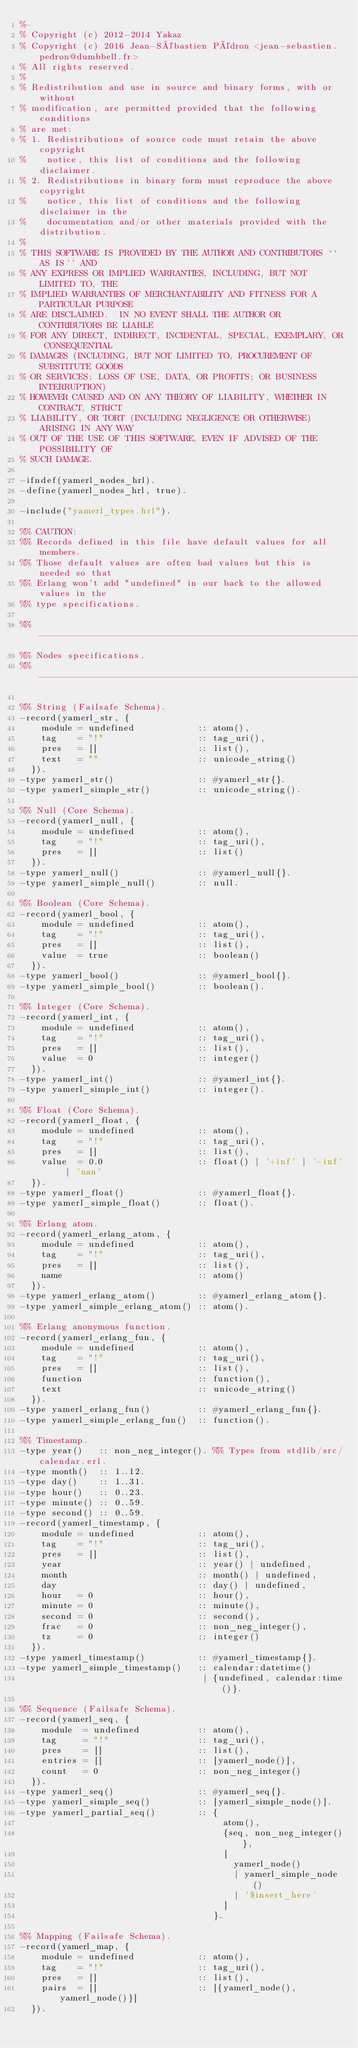<code> <loc_0><loc_0><loc_500><loc_500><_Erlang_>%-
% Copyright (c) 2012-2014 Yakaz
% Copyright (c) 2016 Jean-Sébastien Pédron <jean-sebastien.pedron@dumbbell.fr>
% All rights reserved.
%
% Redistribution and use in source and binary forms, with or without
% modification, are permitted provided that the following conditions
% are met:
% 1. Redistributions of source code must retain the above copyright
%    notice, this list of conditions and the following disclaimer.
% 2. Redistributions in binary form must reproduce the above copyright
%    notice, this list of conditions and the following disclaimer in the
%    documentation and/or other materials provided with the distribution.
%
% THIS SOFTWARE IS PROVIDED BY THE AUTHOR AND CONTRIBUTORS ``AS IS'' AND
% ANY EXPRESS OR IMPLIED WARRANTIES, INCLUDING, BUT NOT LIMITED TO, THE
% IMPLIED WARRANTIES OF MERCHANTABILITY AND FITNESS FOR A PARTICULAR PURPOSE
% ARE DISCLAIMED.  IN NO EVENT SHALL THE AUTHOR OR CONTRIBUTORS BE LIABLE
% FOR ANY DIRECT, INDIRECT, INCIDENTAL, SPECIAL, EXEMPLARY, OR CONSEQUENTIAL
% DAMAGES (INCLUDING, BUT NOT LIMITED TO, PROCUREMENT OF SUBSTITUTE GOODS
% OR SERVICES; LOSS OF USE, DATA, OR PROFITS; OR BUSINESS INTERRUPTION)
% HOWEVER CAUSED AND ON ANY THEORY OF LIABILITY, WHETHER IN CONTRACT, STRICT
% LIABILITY, OR TORT (INCLUDING NEGLIGENCE OR OTHERWISE) ARISING IN ANY WAY
% OUT OF THE USE OF THIS SOFTWARE, EVEN IF ADVISED OF THE POSSIBILITY OF
% SUCH DAMAGE.

-ifndef(yamerl_nodes_hrl).
-define(yamerl_nodes_hrl, true).

-include("yamerl_types.hrl").

%% CAUTION:
%% Records defined in this file have default values for all members.
%% Those default values are often bad values but this is needed so that
%% Erlang won't add "undefined" in our back to the allowed values in the
%% type specifications.

%% -------------------------------------------------------------------
%% Nodes specifications.
%% -------------------------------------------------------------------

%% String (Failsafe Schema).
-record(yamerl_str, {
    module = undefined            :: atom(),
    tag    = "!"                  :: tag_uri(),
    pres   = []                   :: list(),
    text   = ""                   :: unicode_string()
  }).
-type yamerl_str()                :: #yamerl_str{}.
-type yamerl_simple_str()         :: unicode_string().

%% Null (Core Schema).
-record(yamerl_null, {
    module = undefined            :: atom(),
    tag    = "!"                  :: tag_uri(),
    pres   = []                   :: list()
  }).
-type yamerl_null()               :: #yamerl_null{}.
-type yamerl_simple_null()        :: null.

%% Boolean (Core Schema).
-record(yamerl_bool, {
    module = undefined            :: atom(),
    tag    = "!"                  :: tag_uri(),
    pres   = []                   :: list(),
    value  = true                 :: boolean()
  }).
-type yamerl_bool()               :: #yamerl_bool{}.
-type yamerl_simple_bool()        :: boolean().

%% Integer (Core Schema).
-record(yamerl_int, {
    module = undefined            :: atom(),
    tag    = "!"                  :: tag_uri(),
    pres   = []                   :: list(),
    value  = 0                    :: integer()
  }).
-type yamerl_int()                :: #yamerl_int{}.
-type yamerl_simple_int()         :: integer().

%% Float (Core Schema).
-record(yamerl_float, {
    module = undefined            :: atom(),
    tag    = "!"                  :: tag_uri(),
    pres   = []                   :: list(),
    value  = 0.0                  :: float() | '+inf' | '-inf' | 'nan'
  }).
-type yamerl_float()              :: #yamerl_float{}.
-type yamerl_simple_float()       :: float().

%% Erlang atom.
-record(yamerl_erlang_atom, {
    module = undefined            :: atom(),
    tag    = "!"                  :: tag_uri(),
    pres   = []                   :: list(),
    name                          :: atom()
  }).
-type yamerl_erlang_atom()        :: #yamerl_erlang_atom{}.
-type yamerl_simple_erlang_atom() :: atom().

%% Erlang anonymous function.
-record(yamerl_erlang_fun, {
    module = undefined            :: atom(),
    tag    = "!"                  :: tag_uri(),
    pres   = []                   :: list(),
    function                      :: function(),
    text                          :: unicode_string()
  }).
-type yamerl_erlang_fun()         :: #yamerl_erlang_fun{}.
-type yamerl_simple_erlang_fun()  :: function().

%% Timestamp.
-type year()   :: non_neg_integer(). %% Types from stdlib/src/calendar.erl.
-type month()  :: 1..12.
-type day()    :: 1..31.
-type hour()   :: 0..23.
-type minute() :: 0..59.
-type second() :: 0..59.
-record(yamerl_timestamp, {
    module = undefined            :: atom(),
    tag    = "!"                  :: tag_uri(),
    pres   = []                   :: list(),
    year                          :: year() | undefined,
    month                         :: month() | undefined,
    day                           :: day() | undefined,
    hour   = 0                    :: hour(),
    minute = 0                    :: minute(),
    second = 0                    :: second(),
    frac   = 0                    :: non_neg_integer(),
    tz     = 0                    :: integer()
  }).
-type yamerl_timestamp()          :: #yamerl_timestamp{}.
-type yamerl_simple_timestamp()   :: calendar:datetime()
                                   | {undefined, calendar:time()}.

%% Sequence (Failsafe Schema).
-record(yamerl_seq, {
    module  = undefined           :: atom(),
    tag     = "!"                 :: tag_uri(),
    pres    = []                  :: list(),
    entries = []                  :: [yamerl_node()],
    count   = 0                   :: non_neg_integer()
  }).
-type yamerl_seq()                :: #yamerl_seq{}.
-type yamerl_simple_seq()         :: [yamerl_simple_node()].
-type yamerl_partial_seq()        :: {
                                       atom(),
                                       {seq, non_neg_integer()},
                                       [
                                         yamerl_node()
                                         | yamerl_simple_node()
                                         | '$insert_here'
                                       ]
                                     }.

%% Mapping (Failsafe Schema).
-record(yamerl_map, {
    module = undefined            :: atom(),
    tag    = "!"                  :: tag_uri(),
    pres   = []                   :: list(),
    pairs  = []                   :: [{yamerl_node(), yamerl_node()}]
  }).</code> 